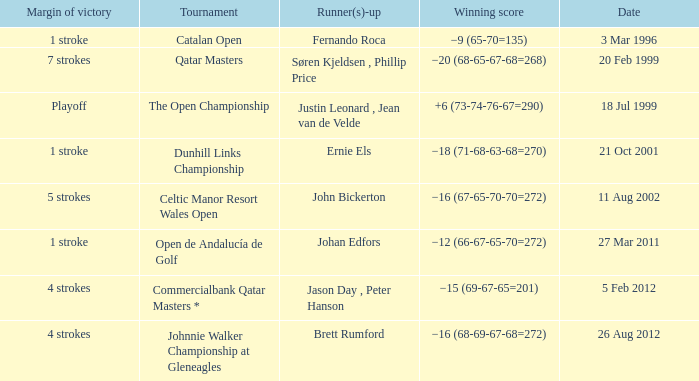What is the winning score for the runner-up Ernie Els? −18 (71-68-63-68=270). 